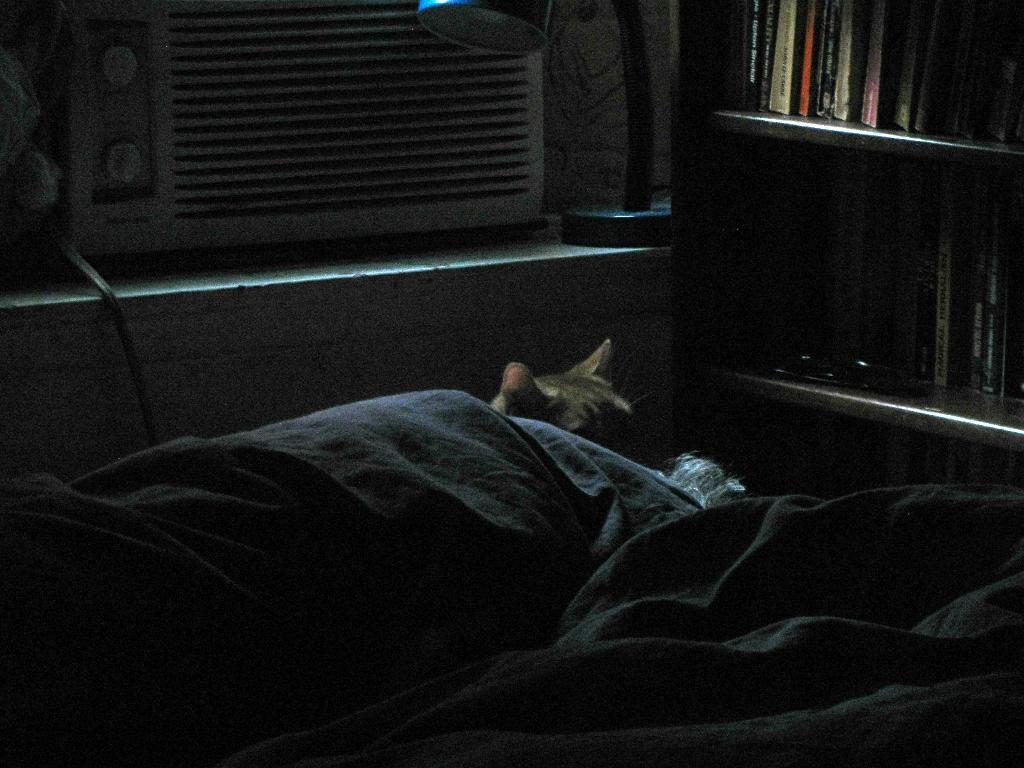Describe this image in one or two sentences. In this image I can see a cloth in the front and behind it I can see a cat. On the right side of this image I can see number of books on the shelves. On the top of this image I can see an air cooler and a lamp. 